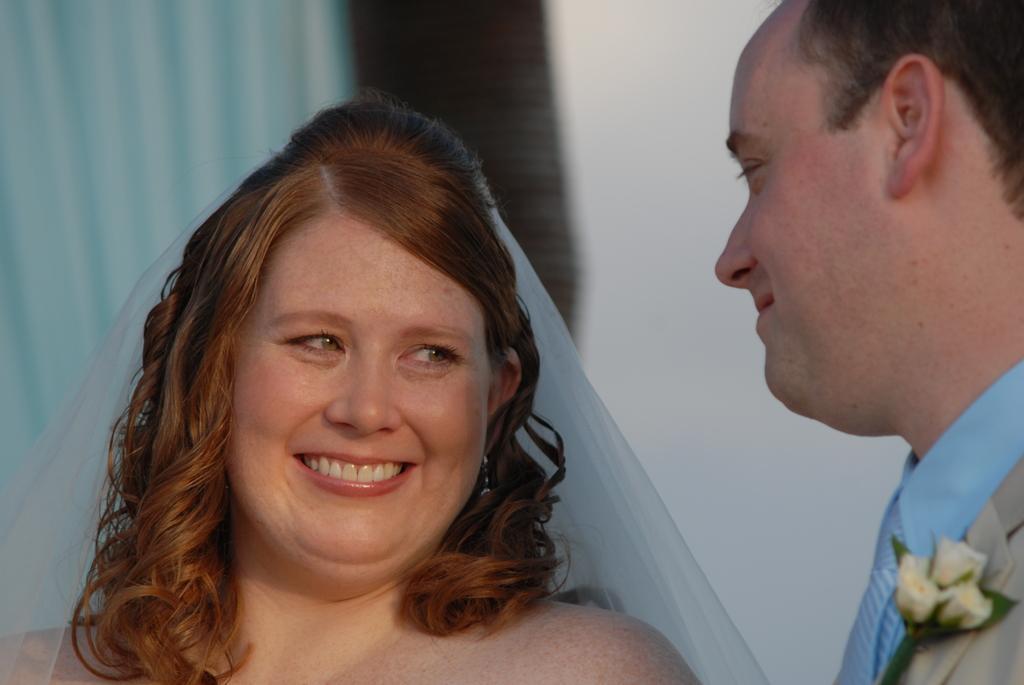In one or two sentences, can you explain what this image depicts? In this image we can able to see a couple, the man is wearing blue color shirt and a gray color suit, and there is a flower on it. 